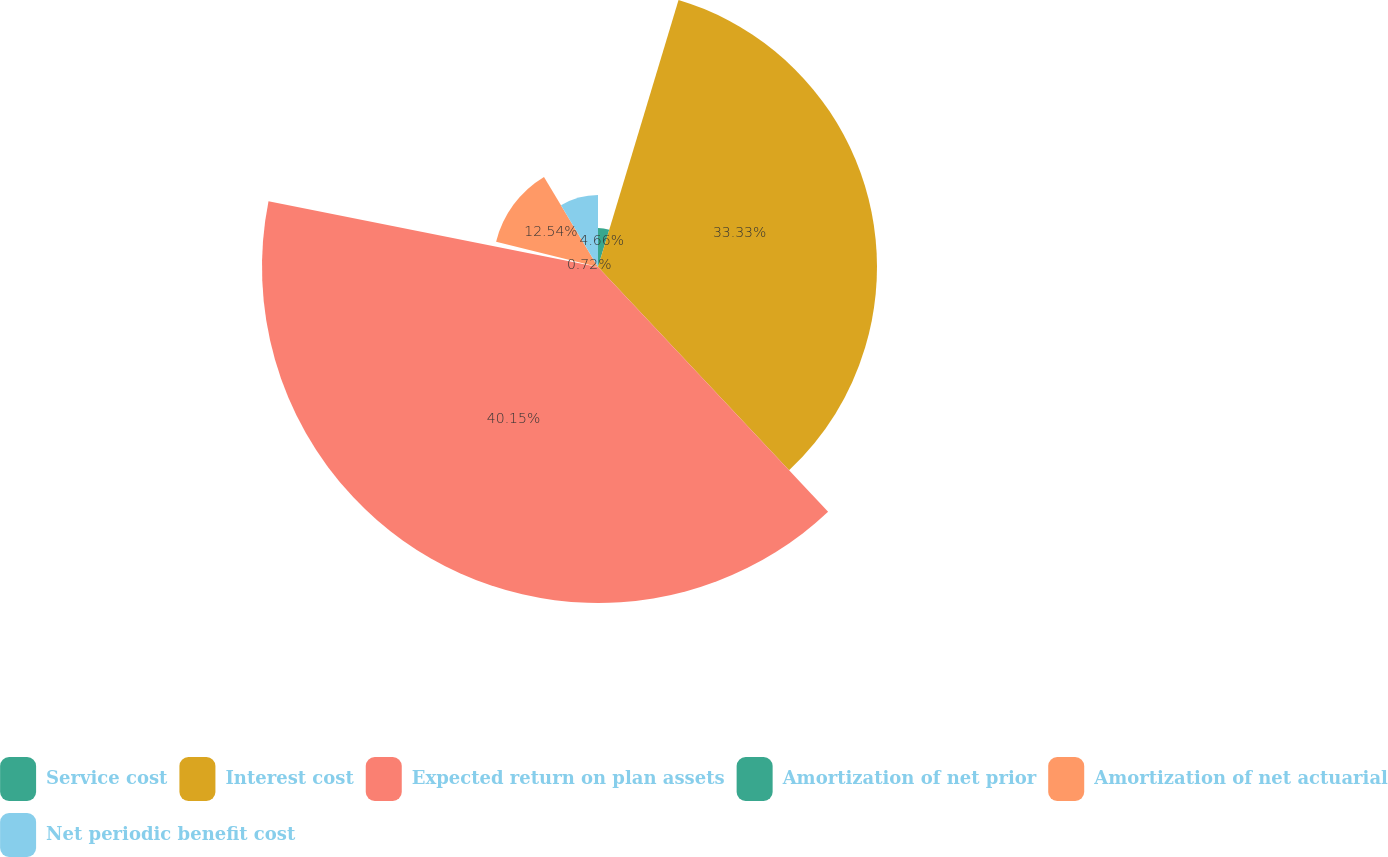<chart> <loc_0><loc_0><loc_500><loc_500><pie_chart><fcel>Service cost<fcel>Interest cost<fcel>Expected return on plan assets<fcel>Amortization of net prior<fcel>Amortization of net actuarial<fcel>Net periodic benefit cost<nl><fcel>4.66%<fcel>33.33%<fcel>40.14%<fcel>0.72%<fcel>12.54%<fcel>8.6%<nl></chart> 